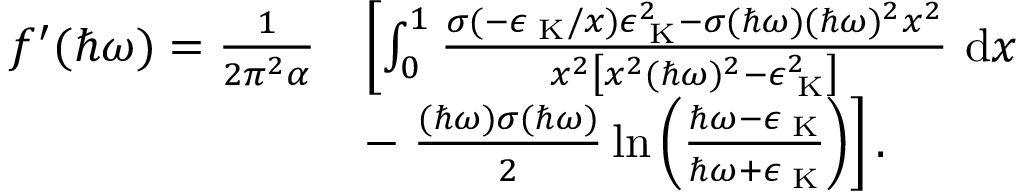Convert formula to latex. <formula><loc_0><loc_0><loc_500><loc_500>\begin{array} { r l } { f ^ { \prime } ( \hbar { \omega } ) = \frac { 1 } { 2 \pi ^ { 2 } \alpha } } & { \left [ \int _ { 0 } ^ { 1 } \frac { \sigma ( - \epsilon _ { K } / x ) \epsilon _ { K } ^ { 2 } - \sigma ( \hbar { \omega } ) ( \hbar { \omega } ) ^ { 2 } x ^ { 2 } } { x ^ { 2 } \left [ x ^ { 2 } ( \hbar { \omega } ) ^ { 2 } - \epsilon _ { K } ^ { 2 } \right ] } d x } \\ & { - \frac { ( \hbar { \omega } ) \sigma ( \hbar { \omega } ) } { 2 } \ln { \left ( \frac { \hbar { \omega } - \epsilon _ { K } } { \hbar { \omega } + \epsilon _ { K } } \right ) } \right ] . } \end{array}</formula> 